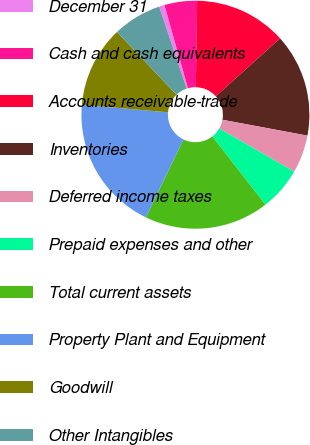<chart> <loc_0><loc_0><loc_500><loc_500><pie_chart><fcel>December 31<fcel>Cash and cash equivalents<fcel>Accounts receivable-trade<fcel>Inventories<fcel>Deferred income taxes<fcel>Prepaid expenses and other<fcel>Total current assets<fcel>Property Plant and Equipment<fcel>Goodwill<fcel>Other Intangibles<nl><fcel>0.77%<fcel>4.62%<fcel>13.08%<fcel>14.62%<fcel>5.38%<fcel>6.15%<fcel>17.69%<fcel>19.23%<fcel>11.54%<fcel>6.92%<nl></chart> 